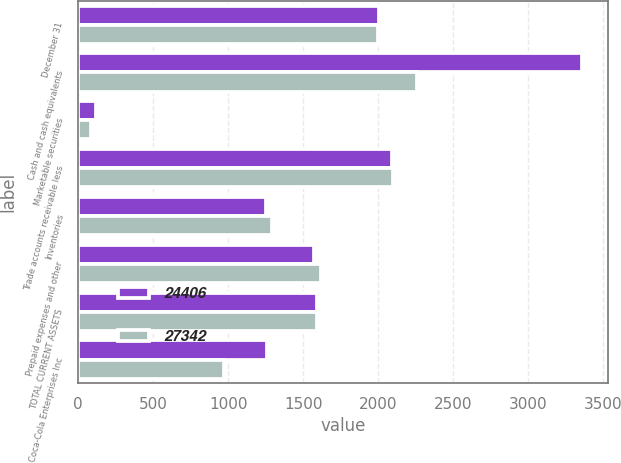Convert chart. <chart><loc_0><loc_0><loc_500><loc_500><stacked_bar_chart><ecel><fcel>December 31<fcel>Cash and cash equivalents<fcel>Marketable securities<fcel>Trade accounts receivable less<fcel>Inventories<fcel>Prepaid expenses and other<fcel>TOTAL CURRENT ASSETS<fcel>Coca-Cola Enterprises Inc<nl><fcel>24406<fcel>2003<fcel>3362<fcel>120<fcel>2091<fcel>1252<fcel>1571<fcel>1593.5<fcel>1260<nl><fcel>27342<fcel>2002<fcel>2260<fcel>85<fcel>2097<fcel>1294<fcel>1616<fcel>1593.5<fcel>972<nl></chart> 